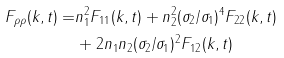<formula> <loc_0><loc_0><loc_500><loc_500>F _ { \rho \rho } ( { k } , t ) = & n _ { 1 } ^ { 2 } F _ { 1 1 } ( { k } , t ) + n _ { 2 } ^ { 2 } ( \sigma _ { 2 } / \sigma _ { 1 } ) ^ { 4 } F _ { 2 2 } ( { k } , t ) \\ & + 2 n _ { 1 } n _ { 2 } ( \sigma _ { 2 } / \sigma _ { 1 } ) ^ { 2 } F _ { 1 2 } ( { k } , t )</formula> 